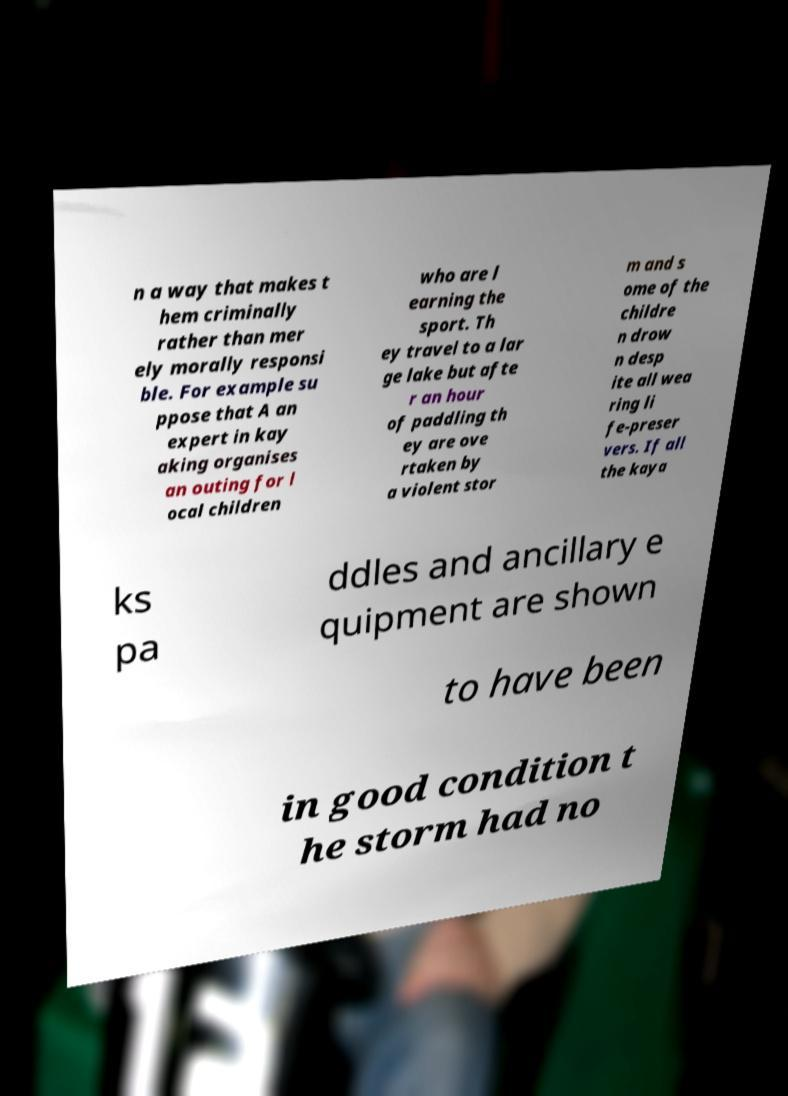There's text embedded in this image that I need extracted. Can you transcribe it verbatim? n a way that makes t hem criminally rather than mer ely morally responsi ble. For example su ppose that A an expert in kay aking organises an outing for l ocal children who are l earning the sport. Th ey travel to a lar ge lake but afte r an hour of paddling th ey are ove rtaken by a violent stor m and s ome of the childre n drow n desp ite all wea ring li fe-preser vers. If all the kaya ks pa ddles and ancillary e quipment are shown to have been in good condition t he storm had no 